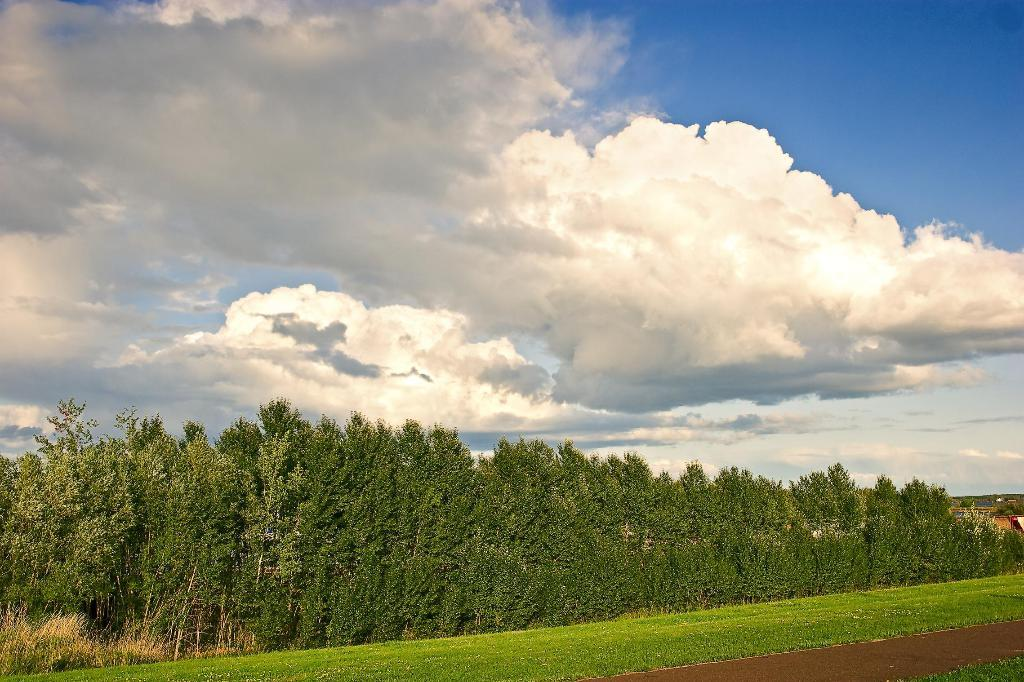What type of vegetation can be seen in the image? There are trees in the image. What is present at the bottom of the image? There is grass at the bottom of the image. What is visible at the top of the image? The sky is visible at the top of the image. How would you describe the sky in the image? The sky appears to be cloudy. What letters can be seen on the grass in the image? There are no letters present on the grass in the image. How does the bit of information feel in the image? There is no bit of information present in the image, so it cannot be felt. 